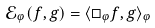Convert formula to latex. <formula><loc_0><loc_0><loc_500><loc_500>\mathcal { E } _ { \varphi } ( f , g ) = \langle \Box _ { \varphi } f , g \rangle _ { \varphi }</formula> 